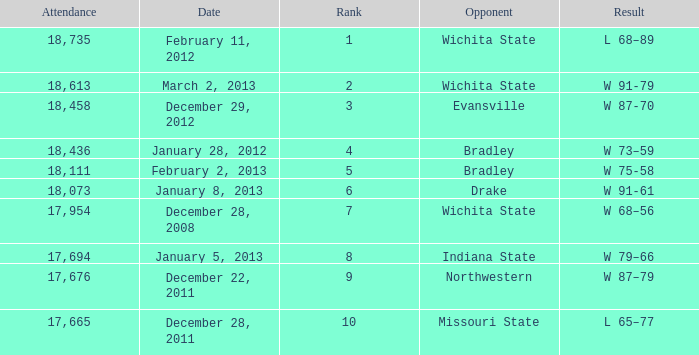What is the position for february 11, 2012 with under 18,735 attendees? None. 